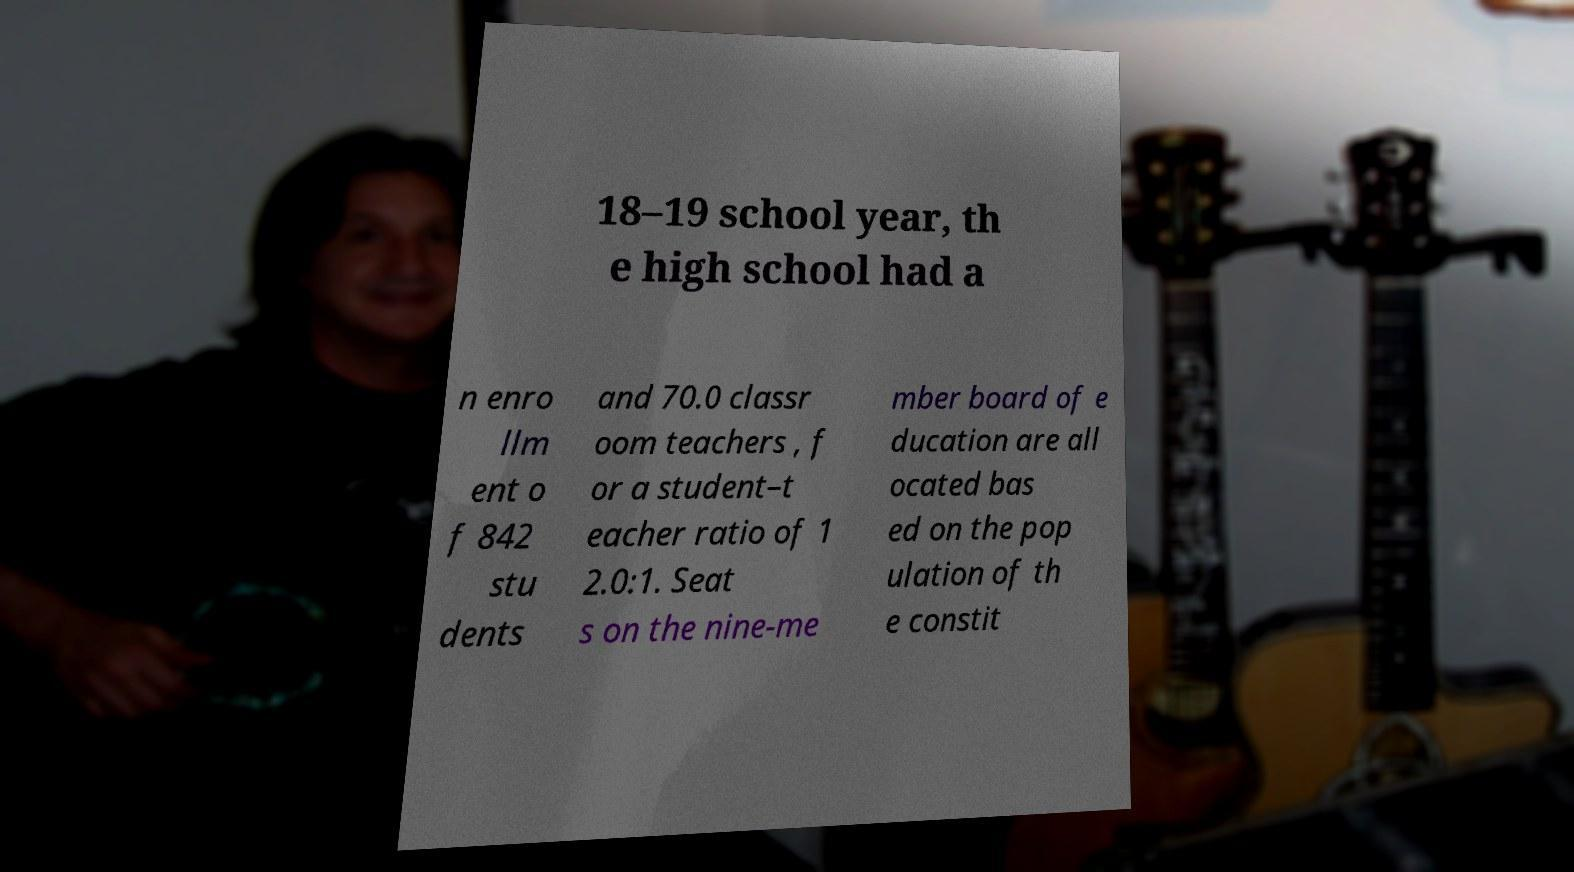Can you accurately transcribe the text from the provided image for me? 18–19 school year, th e high school had a n enro llm ent o f 842 stu dents and 70.0 classr oom teachers , f or a student–t eacher ratio of 1 2.0:1. Seat s on the nine-me mber board of e ducation are all ocated bas ed on the pop ulation of th e constit 